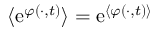Convert formula to latex. <formula><loc_0><loc_0><loc_500><loc_500>\langle e ^ { \varphi ( \cdot , t ) } \rangle = e ^ { \langle \varphi ( \cdot , t ) \rangle }</formula> 